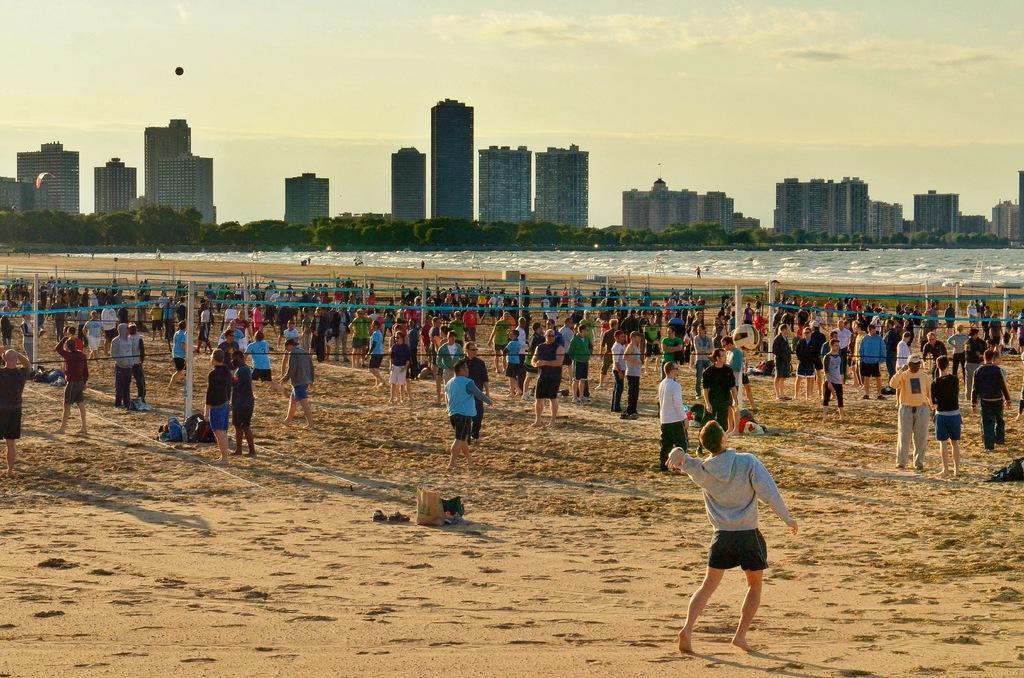How would you summarize this image in a sentence or two? There are people and we can see ball in the air. We can see objects on the sand, nets and poles. In the background we can see water, buildings, trees, paragliding and sky. 